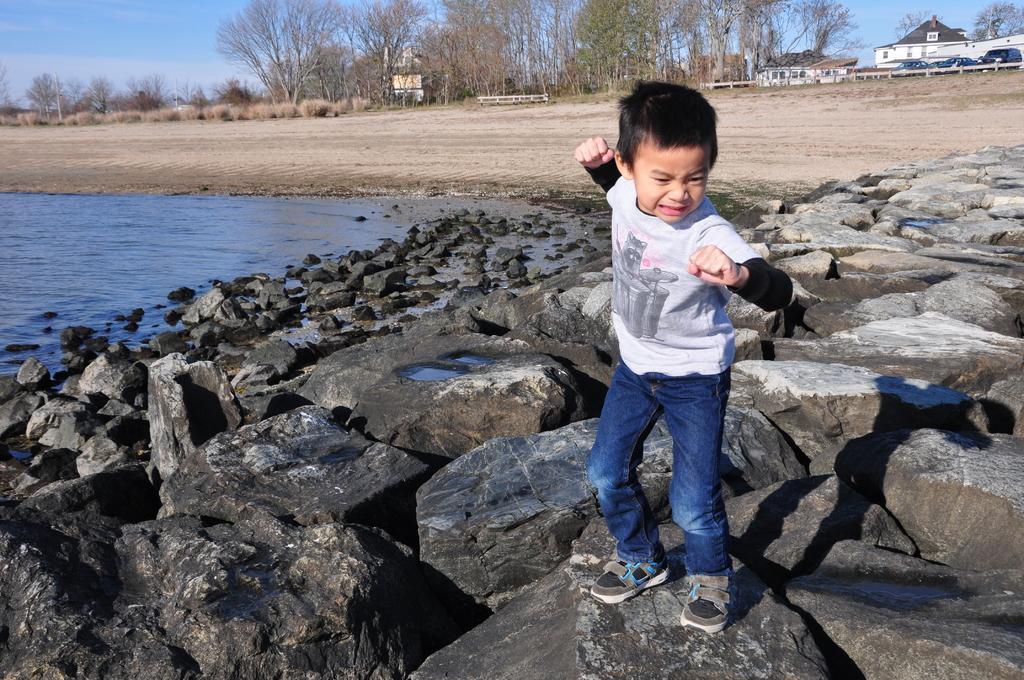How would you summarize this image in a sentence or two? In this image there is a boy standing on the stone. Around him there are so many stones. On the left side there is water. In the background there is a ground on which there are tall trees. On the right side top there are houses and vehicles. 